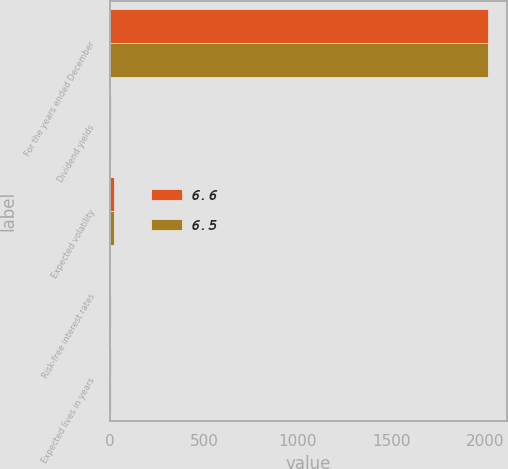<chart> <loc_0><loc_0><loc_500><loc_500><stacked_bar_chart><ecel><fcel>For the years ended December<fcel>Dividend yields<fcel>Expected volatility<fcel>Risk-free interest rates<fcel>Expected lives in years<nl><fcel>6.6<fcel>2012<fcel>2.4<fcel>22.4<fcel>1.5<fcel>6.6<nl><fcel>6.5<fcel>2011<fcel>2.7<fcel>22.5<fcel>2.8<fcel>6.5<nl></chart> 